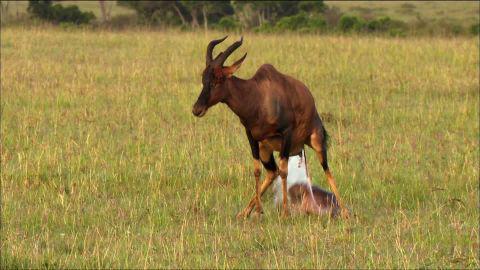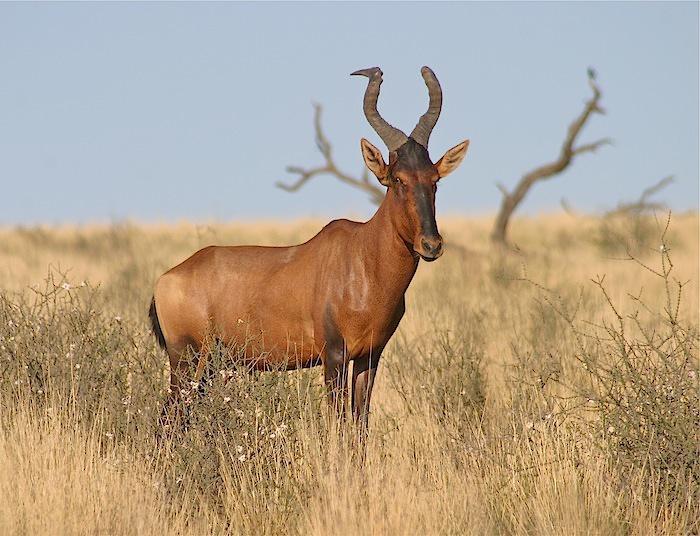The first image is the image on the left, the second image is the image on the right. Examine the images to the left and right. Is the description "Lefthand image contains two horned animals standing in a field." accurate? Answer yes or no. No. The first image is the image on the left, the second image is the image on the right. Assess this claim about the two images: "One of the images shows exactly two antelopes that are standing.". Correct or not? Answer yes or no. No. 